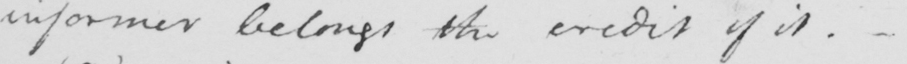Please provide the text content of this handwritten line. informer belongs the credit of it .  _ 